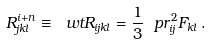<formula> <loc_0><loc_0><loc_500><loc_500>R ^ { i + n } _ { j k l } \equiv \ w t R _ { i j k l } = \frac { 1 } { 3 } \ p r ^ { 2 } _ { i j } F _ { k l } \, .</formula> 